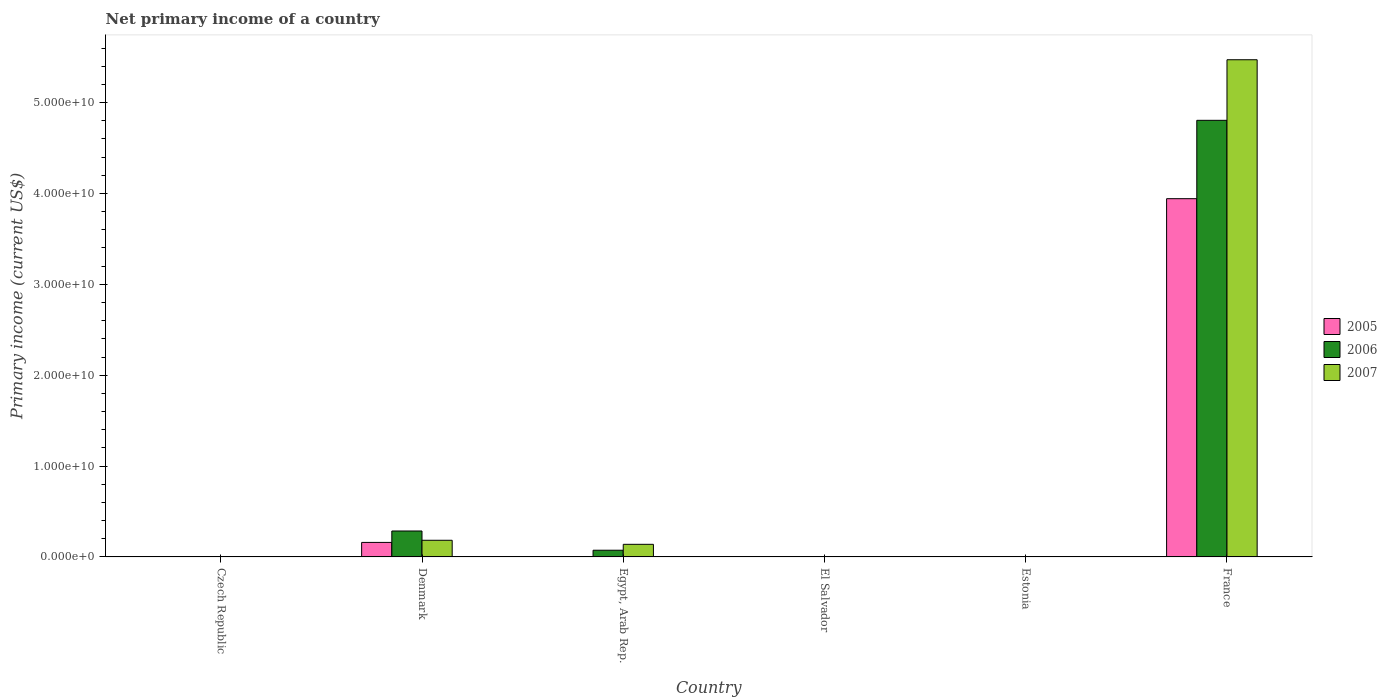Are the number of bars per tick equal to the number of legend labels?
Give a very brief answer. No. Are the number of bars on each tick of the X-axis equal?
Your answer should be compact. No. How many bars are there on the 4th tick from the left?
Keep it short and to the point. 0. What is the label of the 3rd group of bars from the left?
Make the answer very short. Egypt, Arab Rep. What is the primary income in 2005 in El Salvador?
Give a very brief answer. 0. Across all countries, what is the maximum primary income in 2007?
Your response must be concise. 5.47e+1. Across all countries, what is the minimum primary income in 2006?
Provide a succinct answer. 0. In which country was the primary income in 2007 maximum?
Make the answer very short. France. What is the total primary income in 2007 in the graph?
Offer a terse response. 5.79e+1. What is the difference between the primary income in 2007 in France and the primary income in 2006 in Czech Republic?
Make the answer very short. 5.47e+1. What is the average primary income in 2006 per country?
Keep it short and to the point. 8.61e+09. What is the difference between the primary income of/in 2006 and primary income of/in 2005 in France?
Provide a short and direct response. 8.62e+09. In how many countries, is the primary income in 2007 greater than 36000000000 US$?
Offer a very short reply. 1. Is the primary income in 2005 in Denmark less than that in France?
Make the answer very short. Yes. What is the difference between the highest and the second highest primary income in 2007?
Keep it short and to the point. 5.29e+1. What is the difference between the highest and the lowest primary income in 2005?
Your response must be concise. 3.94e+1. In how many countries, is the primary income in 2005 greater than the average primary income in 2005 taken over all countries?
Keep it short and to the point. 1. Is it the case that in every country, the sum of the primary income in 2006 and primary income in 2007 is greater than the primary income in 2005?
Keep it short and to the point. No. How many bars are there?
Your answer should be compact. 8. Are all the bars in the graph horizontal?
Provide a succinct answer. No. How many countries are there in the graph?
Offer a very short reply. 6. What is the difference between two consecutive major ticks on the Y-axis?
Make the answer very short. 1.00e+1. How many legend labels are there?
Provide a succinct answer. 3. What is the title of the graph?
Your answer should be very brief. Net primary income of a country. What is the label or title of the Y-axis?
Your answer should be compact. Primary income (current US$). What is the Primary income (current US$) of 2005 in Denmark?
Offer a very short reply. 1.60e+09. What is the Primary income (current US$) in 2006 in Denmark?
Your answer should be very brief. 2.85e+09. What is the Primary income (current US$) in 2007 in Denmark?
Give a very brief answer. 1.83e+09. What is the Primary income (current US$) in 2005 in Egypt, Arab Rep.?
Keep it short and to the point. 0. What is the Primary income (current US$) in 2006 in Egypt, Arab Rep.?
Your response must be concise. 7.38e+08. What is the Primary income (current US$) in 2007 in Egypt, Arab Rep.?
Offer a terse response. 1.39e+09. What is the Primary income (current US$) in 2007 in El Salvador?
Provide a succinct answer. 0. What is the Primary income (current US$) of 2005 in Estonia?
Provide a succinct answer. 0. What is the Primary income (current US$) in 2006 in Estonia?
Your answer should be very brief. 0. What is the Primary income (current US$) of 2007 in Estonia?
Offer a terse response. 0. What is the Primary income (current US$) in 2005 in France?
Your answer should be compact. 3.94e+1. What is the Primary income (current US$) of 2006 in France?
Your answer should be very brief. 4.80e+1. What is the Primary income (current US$) of 2007 in France?
Offer a terse response. 5.47e+1. Across all countries, what is the maximum Primary income (current US$) of 2005?
Keep it short and to the point. 3.94e+1. Across all countries, what is the maximum Primary income (current US$) of 2006?
Your answer should be compact. 4.80e+1. Across all countries, what is the maximum Primary income (current US$) in 2007?
Provide a succinct answer. 5.47e+1. Across all countries, what is the minimum Primary income (current US$) in 2005?
Your answer should be very brief. 0. What is the total Primary income (current US$) of 2005 in the graph?
Keep it short and to the point. 4.10e+1. What is the total Primary income (current US$) of 2006 in the graph?
Ensure brevity in your answer.  5.16e+1. What is the total Primary income (current US$) of 2007 in the graph?
Provide a short and direct response. 5.79e+1. What is the difference between the Primary income (current US$) in 2006 in Denmark and that in Egypt, Arab Rep.?
Offer a very short reply. 2.12e+09. What is the difference between the Primary income (current US$) in 2007 in Denmark and that in Egypt, Arab Rep.?
Offer a terse response. 4.44e+08. What is the difference between the Primary income (current US$) of 2005 in Denmark and that in France?
Offer a very short reply. -3.78e+1. What is the difference between the Primary income (current US$) of 2006 in Denmark and that in France?
Give a very brief answer. -4.52e+1. What is the difference between the Primary income (current US$) in 2007 in Denmark and that in France?
Provide a succinct answer. -5.29e+1. What is the difference between the Primary income (current US$) in 2006 in Egypt, Arab Rep. and that in France?
Your response must be concise. -4.73e+1. What is the difference between the Primary income (current US$) of 2007 in Egypt, Arab Rep. and that in France?
Give a very brief answer. -5.33e+1. What is the difference between the Primary income (current US$) of 2005 in Denmark and the Primary income (current US$) of 2006 in Egypt, Arab Rep.?
Your answer should be compact. 8.60e+08. What is the difference between the Primary income (current US$) of 2005 in Denmark and the Primary income (current US$) of 2007 in Egypt, Arab Rep.?
Give a very brief answer. 2.10e+08. What is the difference between the Primary income (current US$) in 2006 in Denmark and the Primary income (current US$) in 2007 in Egypt, Arab Rep.?
Keep it short and to the point. 1.47e+09. What is the difference between the Primary income (current US$) in 2005 in Denmark and the Primary income (current US$) in 2006 in France?
Offer a terse response. -4.65e+1. What is the difference between the Primary income (current US$) of 2005 in Denmark and the Primary income (current US$) of 2007 in France?
Your answer should be very brief. -5.31e+1. What is the difference between the Primary income (current US$) in 2006 in Denmark and the Primary income (current US$) in 2007 in France?
Your answer should be very brief. -5.19e+1. What is the difference between the Primary income (current US$) in 2006 in Egypt, Arab Rep. and the Primary income (current US$) in 2007 in France?
Offer a very short reply. -5.40e+1. What is the average Primary income (current US$) in 2005 per country?
Ensure brevity in your answer.  6.84e+09. What is the average Primary income (current US$) in 2006 per country?
Offer a terse response. 8.61e+09. What is the average Primary income (current US$) of 2007 per country?
Provide a short and direct response. 9.66e+09. What is the difference between the Primary income (current US$) in 2005 and Primary income (current US$) in 2006 in Denmark?
Provide a short and direct response. -1.26e+09. What is the difference between the Primary income (current US$) of 2005 and Primary income (current US$) of 2007 in Denmark?
Make the answer very short. -2.35e+08. What is the difference between the Primary income (current US$) of 2006 and Primary income (current US$) of 2007 in Denmark?
Provide a short and direct response. 1.02e+09. What is the difference between the Primary income (current US$) of 2006 and Primary income (current US$) of 2007 in Egypt, Arab Rep.?
Your answer should be very brief. -6.50e+08. What is the difference between the Primary income (current US$) of 2005 and Primary income (current US$) of 2006 in France?
Offer a terse response. -8.62e+09. What is the difference between the Primary income (current US$) in 2005 and Primary income (current US$) in 2007 in France?
Ensure brevity in your answer.  -1.53e+1. What is the difference between the Primary income (current US$) in 2006 and Primary income (current US$) in 2007 in France?
Your answer should be compact. -6.67e+09. What is the ratio of the Primary income (current US$) in 2006 in Denmark to that in Egypt, Arab Rep.?
Provide a short and direct response. 3.87. What is the ratio of the Primary income (current US$) of 2007 in Denmark to that in Egypt, Arab Rep.?
Your answer should be compact. 1.32. What is the ratio of the Primary income (current US$) of 2005 in Denmark to that in France?
Give a very brief answer. 0.04. What is the ratio of the Primary income (current US$) of 2006 in Denmark to that in France?
Ensure brevity in your answer.  0.06. What is the ratio of the Primary income (current US$) in 2007 in Denmark to that in France?
Provide a short and direct response. 0.03. What is the ratio of the Primary income (current US$) of 2006 in Egypt, Arab Rep. to that in France?
Keep it short and to the point. 0.02. What is the ratio of the Primary income (current US$) of 2007 in Egypt, Arab Rep. to that in France?
Ensure brevity in your answer.  0.03. What is the difference between the highest and the second highest Primary income (current US$) of 2006?
Make the answer very short. 4.52e+1. What is the difference between the highest and the second highest Primary income (current US$) of 2007?
Offer a very short reply. 5.29e+1. What is the difference between the highest and the lowest Primary income (current US$) in 2005?
Your answer should be very brief. 3.94e+1. What is the difference between the highest and the lowest Primary income (current US$) of 2006?
Offer a very short reply. 4.80e+1. What is the difference between the highest and the lowest Primary income (current US$) of 2007?
Provide a short and direct response. 5.47e+1. 